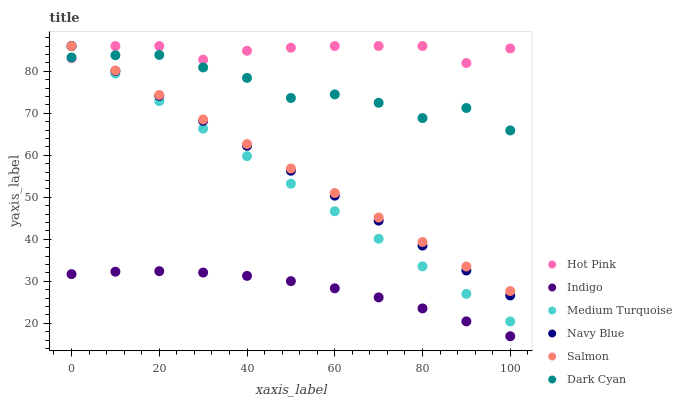Does Indigo have the minimum area under the curve?
Answer yes or no. Yes. Does Hot Pink have the maximum area under the curve?
Answer yes or no. Yes. Does Navy Blue have the minimum area under the curve?
Answer yes or no. No. Does Navy Blue have the maximum area under the curve?
Answer yes or no. No. Is Navy Blue the smoothest?
Answer yes or no. Yes. Is Dark Cyan the roughest?
Answer yes or no. Yes. Is Hot Pink the smoothest?
Answer yes or no. No. Is Hot Pink the roughest?
Answer yes or no. No. Does Indigo have the lowest value?
Answer yes or no. Yes. Does Navy Blue have the lowest value?
Answer yes or no. No. Does Medium Turquoise have the highest value?
Answer yes or no. Yes. Does Dark Cyan have the highest value?
Answer yes or no. No. Is Indigo less than Salmon?
Answer yes or no. Yes. Is Salmon greater than Indigo?
Answer yes or no. Yes. Does Hot Pink intersect Medium Turquoise?
Answer yes or no. Yes. Is Hot Pink less than Medium Turquoise?
Answer yes or no. No. Is Hot Pink greater than Medium Turquoise?
Answer yes or no. No. Does Indigo intersect Salmon?
Answer yes or no. No. 